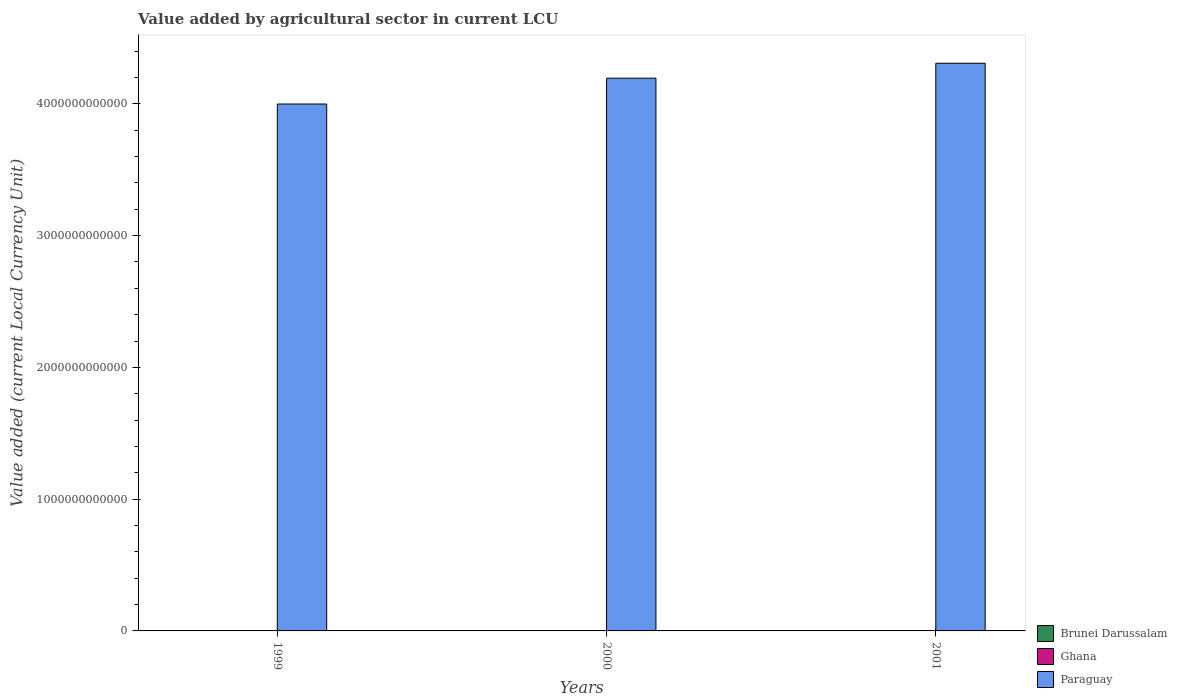Are the number of bars per tick equal to the number of legend labels?
Give a very brief answer. Yes. How many bars are there on the 1st tick from the left?
Your answer should be very brief. 3. What is the label of the 2nd group of bars from the left?
Keep it short and to the point. 2000. In how many cases, is the number of bars for a given year not equal to the number of legend labels?
Provide a short and direct response. 0. What is the value added by agricultural sector in Brunei Darussalam in 2000?
Your answer should be very brief. 1.06e+08. Across all years, what is the maximum value added by agricultural sector in Ghana?
Provide a short and direct response. 1.34e+09. Across all years, what is the minimum value added by agricultural sector in Brunei Darussalam?
Your answer should be compact. 9.63e+07. In which year was the value added by agricultural sector in Ghana maximum?
Provide a short and direct response. 2001. In which year was the value added by agricultural sector in Brunei Darussalam minimum?
Provide a short and direct response. 1999. What is the total value added by agricultural sector in Brunei Darussalam in the graph?
Your response must be concise. 3.16e+08. What is the difference between the value added by agricultural sector in Ghana in 1999 and that in 2000?
Keep it short and to the point. -2.21e+08. What is the difference between the value added by agricultural sector in Ghana in 2001 and the value added by agricultural sector in Paraguay in 1999?
Provide a succinct answer. -4.00e+12. What is the average value added by agricultural sector in Brunei Darussalam per year?
Provide a succinct answer. 1.05e+08. In the year 2000, what is the difference between the value added by agricultural sector in Paraguay and value added by agricultural sector in Brunei Darussalam?
Ensure brevity in your answer.  4.19e+12. In how many years, is the value added by agricultural sector in Ghana greater than 3600000000000 LCU?
Ensure brevity in your answer.  0. What is the ratio of the value added by agricultural sector in Paraguay in 1999 to that in 2000?
Keep it short and to the point. 0.95. What is the difference between the highest and the second highest value added by agricultural sector in Paraguay?
Your answer should be compact. 1.13e+11. What is the difference between the highest and the lowest value added by agricultural sector in Brunei Darussalam?
Your answer should be very brief. 1.76e+07. In how many years, is the value added by agricultural sector in Paraguay greater than the average value added by agricultural sector in Paraguay taken over all years?
Give a very brief answer. 2. What does the 1st bar from the left in 1999 represents?
Offer a terse response. Brunei Darussalam. Is it the case that in every year, the sum of the value added by agricultural sector in Ghana and value added by agricultural sector in Paraguay is greater than the value added by agricultural sector in Brunei Darussalam?
Your answer should be compact. Yes. What is the difference between two consecutive major ticks on the Y-axis?
Your answer should be very brief. 1.00e+12. Does the graph contain any zero values?
Offer a terse response. No. Does the graph contain grids?
Your answer should be very brief. No. What is the title of the graph?
Provide a succinct answer. Value added by agricultural sector in current LCU. What is the label or title of the X-axis?
Give a very brief answer. Years. What is the label or title of the Y-axis?
Provide a succinct answer. Value added (current Local Currency Unit). What is the Value added (current Local Currency Unit) in Brunei Darussalam in 1999?
Provide a succinct answer. 9.63e+07. What is the Value added (current Local Currency Unit) of Ghana in 1999?
Provide a short and direct response. 7.36e+08. What is the Value added (current Local Currency Unit) in Paraguay in 1999?
Make the answer very short. 4.00e+12. What is the Value added (current Local Currency Unit) of Brunei Darussalam in 2000?
Provide a succinct answer. 1.06e+08. What is the Value added (current Local Currency Unit) in Ghana in 2000?
Your response must be concise. 9.58e+08. What is the Value added (current Local Currency Unit) of Paraguay in 2000?
Your answer should be compact. 4.19e+12. What is the Value added (current Local Currency Unit) in Brunei Darussalam in 2001?
Offer a terse response. 1.14e+08. What is the Value added (current Local Currency Unit) of Ghana in 2001?
Keep it short and to the point. 1.34e+09. What is the Value added (current Local Currency Unit) of Paraguay in 2001?
Offer a very short reply. 4.31e+12. Across all years, what is the maximum Value added (current Local Currency Unit) of Brunei Darussalam?
Offer a very short reply. 1.14e+08. Across all years, what is the maximum Value added (current Local Currency Unit) of Ghana?
Offer a terse response. 1.34e+09. Across all years, what is the maximum Value added (current Local Currency Unit) of Paraguay?
Offer a terse response. 4.31e+12. Across all years, what is the minimum Value added (current Local Currency Unit) in Brunei Darussalam?
Keep it short and to the point. 9.63e+07. Across all years, what is the minimum Value added (current Local Currency Unit) of Ghana?
Keep it short and to the point. 7.36e+08. Across all years, what is the minimum Value added (current Local Currency Unit) in Paraguay?
Offer a terse response. 4.00e+12. What is the total Value added (current Local Currency Unit) of Brunei Darussalam in the graph?
Ensure brevity in your answer.  3.16e+08. What is the total Value added (current Local Currency Unit) of Ghana in the graph?
Ensure brevity in your answer.  3.04e+09. What is the total Value added (current Local Currency Unit) of Paraguay in the graph?
Give a very brief answer. 1.25e+13. What is the difference between the Value added (current Local Currency Unit) of Brunei Darussalam in 1999 and that in 2000?
Provide a short and direct response. -9.69e+06. What is the difference between the Value added (current Local Currency Unit) of Ghana in 1999 and that in 2000?
Make the answer very short. -2.21e+08. What is the difference between the Value added (current Local Currency Unit) of Paraguay in 1999 and that in 2000?
Your answer should be very brief. -1.96e+11. What is the difference between the Value added (current Local Currency Unit) of Brunei Darussalam in 1999 and that in 2001?
Offer a very short reply. -1.76e+07. What is the difference between the Value added (current Local Currency Unit) in Ghana in 1999 and that in 2001?
Ensure brevity in your answer.  -6.05e+08. What is the difference between the Value added (current Local Currency Unit) of Paraguay in 1999 and that in 2001?
Provide a succinct answer. -3.09e+11. What is the difference between the Value added (current Local Currency Unit) of Brunei Darussalam in 2000 and that in 2001?
Your answer should be compact. -7.87e+06. What is the difference between the Value added (current Local Currency Unit) of Ghana in 2000 and that in 2001?
Ensure brevity in your answer.  -3.84e+08. What is the difference between the Value added (current Local Currency Unit) of Paraguay in 2000 and that in 2001?
Provide a short and direct response. -1.13e+11. What is the difference between the Value added (current Local Currency Unit) in Brunei Darussalam in 1999 and the Value added (current Local Currency Unit) in Ghana in 2000?
Give a very brief answer. -8.61e+08. What is the difference between the Value added (current Local Currency Unit) in Brunei Darussalam in 1999 and the Value added (current Local Currency Unit) in Paraguay in 2000?
Provide a succinct answer. -4.19e+12. What is the difference between the Value added (current Local Currency Unit) of Ghana in 1999 and the Value added (current Local Currency Unit) of Paraguay in 2000?
Your answer should be compact. -4.19e+12. What is the difference between the Value added (current Local Currency Unit) of Brunei Darussalam in 1999 and the Value added (current Local Currency Unit) of Ghana in 2001?
Your answer should be very brief. -1.25e+09. What is the difference between the Value added (current Local Currency Unit) of Brunei Darussalam in 1999 and the Value added (current Local Currency Unit) of Paraguay in 2001?
Provide a succinct answer. -4.31e+12. What is the difference between the Value added (current Local Currency Unit) of Ghana in 1999 and the Value added (current Local Currency Unit) of Paraguay in 2001?
Your response must be concise. -4.31e+12. What is the difference between the Value added (current Local Currency Unit) in Brunei Darussalam in 2000 and the Value added (current Local Currency Unit) in Ghana in 2001?
Your answer should be very brief. -1.24e+09. What is the difference between the Value added (current Local Currency Unit) of Brunei Darussalam in 2000 and the Value added (current Local Currency Unit) of Paraguay in 2001?
Your answer should be compact. -4.31e+12. What is the difference between the Value added (current Local Currency Unit) of Ghana in 2000 and the Value added (current Local Currency Unit) of Paraguay in 2001?
Offer a very short reply. -4.31e+12. What is the average Value added (current Local Currency Unit) in Brunei Darussalam per year?
Make the answer very short. 1.05e+08. What is the average Value added (current Local Currency Unit) in Ghana per year?
Your response must be concise. 1.01e+09. What is the average Value added (current Local Currency Unit) of Paraguay per year?
Keep it short and to the point. 4.17e+12. In the year 1999, what is the difference between the Value added (current Local Currency Unit) in Brunei Darussalam and Value added (current Local Currency Unit) in Ghana?
Offer a very short reply. -6.40e+08. In the year 1999, what is the difference between the Value added (current Local Currency Unit) of Brunei Darussalam and Value added (current Local Currency Unit) of Paraguay?
Keep it short and to the point. -4.00e+12. In the year 1999, what is the difference between the Value added (current Local Currency Unit) of Ghana and Value added (current Local Currency Unit) of Paraguay?
Give a very brief answer. -4.00e+12. In the year 2000, what is the difference between the Value added (current Local Currency Unit) in Brunei Darussalam and Value added (current Local Currency Unit) in Ghana?
Your answer should be compact. -8.52e+08. In the year 2000, what is the difference between the Value added (current Local Currency Unit) of Brunei Darussalam and Value added (current Local Currency Unit) of Paraguay?
Ensure brevity in your answer.  -4.19e+12. In the year 2000, what is the difference between the Value added (current Local Currency Unit) in Ghana and Value added (current Local Currency Unit) in Paraguay?
Ensure brevity in your answer.  -4.19e+12. In the year 2001, what is the difference between the Value added (current Local Currency Unit) in Brunei Darussalam and Value added (current Local Currency Unit) in Ghana?
Offer a terse response. -1.23e+09. In the year 2001, what is the difference between the Value added (current Local Currency Unit) of Brunei Darussalam and Value added (current Local Currency Unit) of Paraguay?
Provide a succinct answer. -4.31e+12. In the year 2001, what is the difference between the Value added (current Local Currency Unit) in Ghana and Value added (current Local Currency Unit) in Paraguay?
Give a very brief answer. -4.31e+12. What is the ratio of the Value added (current Local Currency Unit) of Brunei Darussalam in 1999 to that in 2000?
Provide a succinct answer. 0.91. What is the ratio of the Value added (current Local Currency Unit) of Ghana in 1999 to that in 2000?
Offer a terse response. 0.77. What is the ratio of the Value added (current Local Currency Unit) of Paraguay in 1999 to that in 2000?
Keep it short and to the point. 0.95. What is the ratio of the Value added (current Local Currency Unit) in Brunei Darussalam in 1999 to that in 2001?
Give a very brief answer. 0.85. What is the ratio of the Value added (current Local Currency Unit) of Ghana in 1999 to that in 2001?
Make the answer very short. 0.55. What is the ratio of the Value added (current Local Currency Unit) of Paraguay in 1999 to that in 2001?
Give a very brief answer. 0.93. What is the ratio of the Value added (current Local Currency Unit) in Brunei Darussalam in 2000 to that in 2001?
Offer a terse response. 0.93. What is the ratio of the Value added (current Local Currency Unit) of Ghana in 2000 to that in 2001?
Ensure brevity in your answer.  0.71. What is the ratio of the Value added (current Local Currency Unit) in Paraguay in 2000 to that in 2001?
Give a very brief answer. 0.97. What is the difference between the highest and the second highest Value added (current Local Currency Unit) of Brunei Darussalam?
Your answer should be compact. 7.87e+06. What is the difference between the highest and the second highest Value added (current Local Currency Unit) of Ghana?
Make the answer very short. 3.84e+08. What is the difference between the highest and the second highest Value added (current Local Currency Unit) of Paraguay?
Keep it short and to the point. 1.13e+11. What is the difference between the highest and the lowest Value added (current Local Currency Unit) in Brunei Darussalam?
Offer a very short reply. 1.76e+07. What is the difference between the highest and the lowest Value added (current Local Currency Unit) in Ghana?
Keep it short and to the point. 6.05e+08. What is the difference between the highest and the lowest Value added (current Local Currency Unit) in Paraguay?
Give a very brief answer. 3.09e+11. 